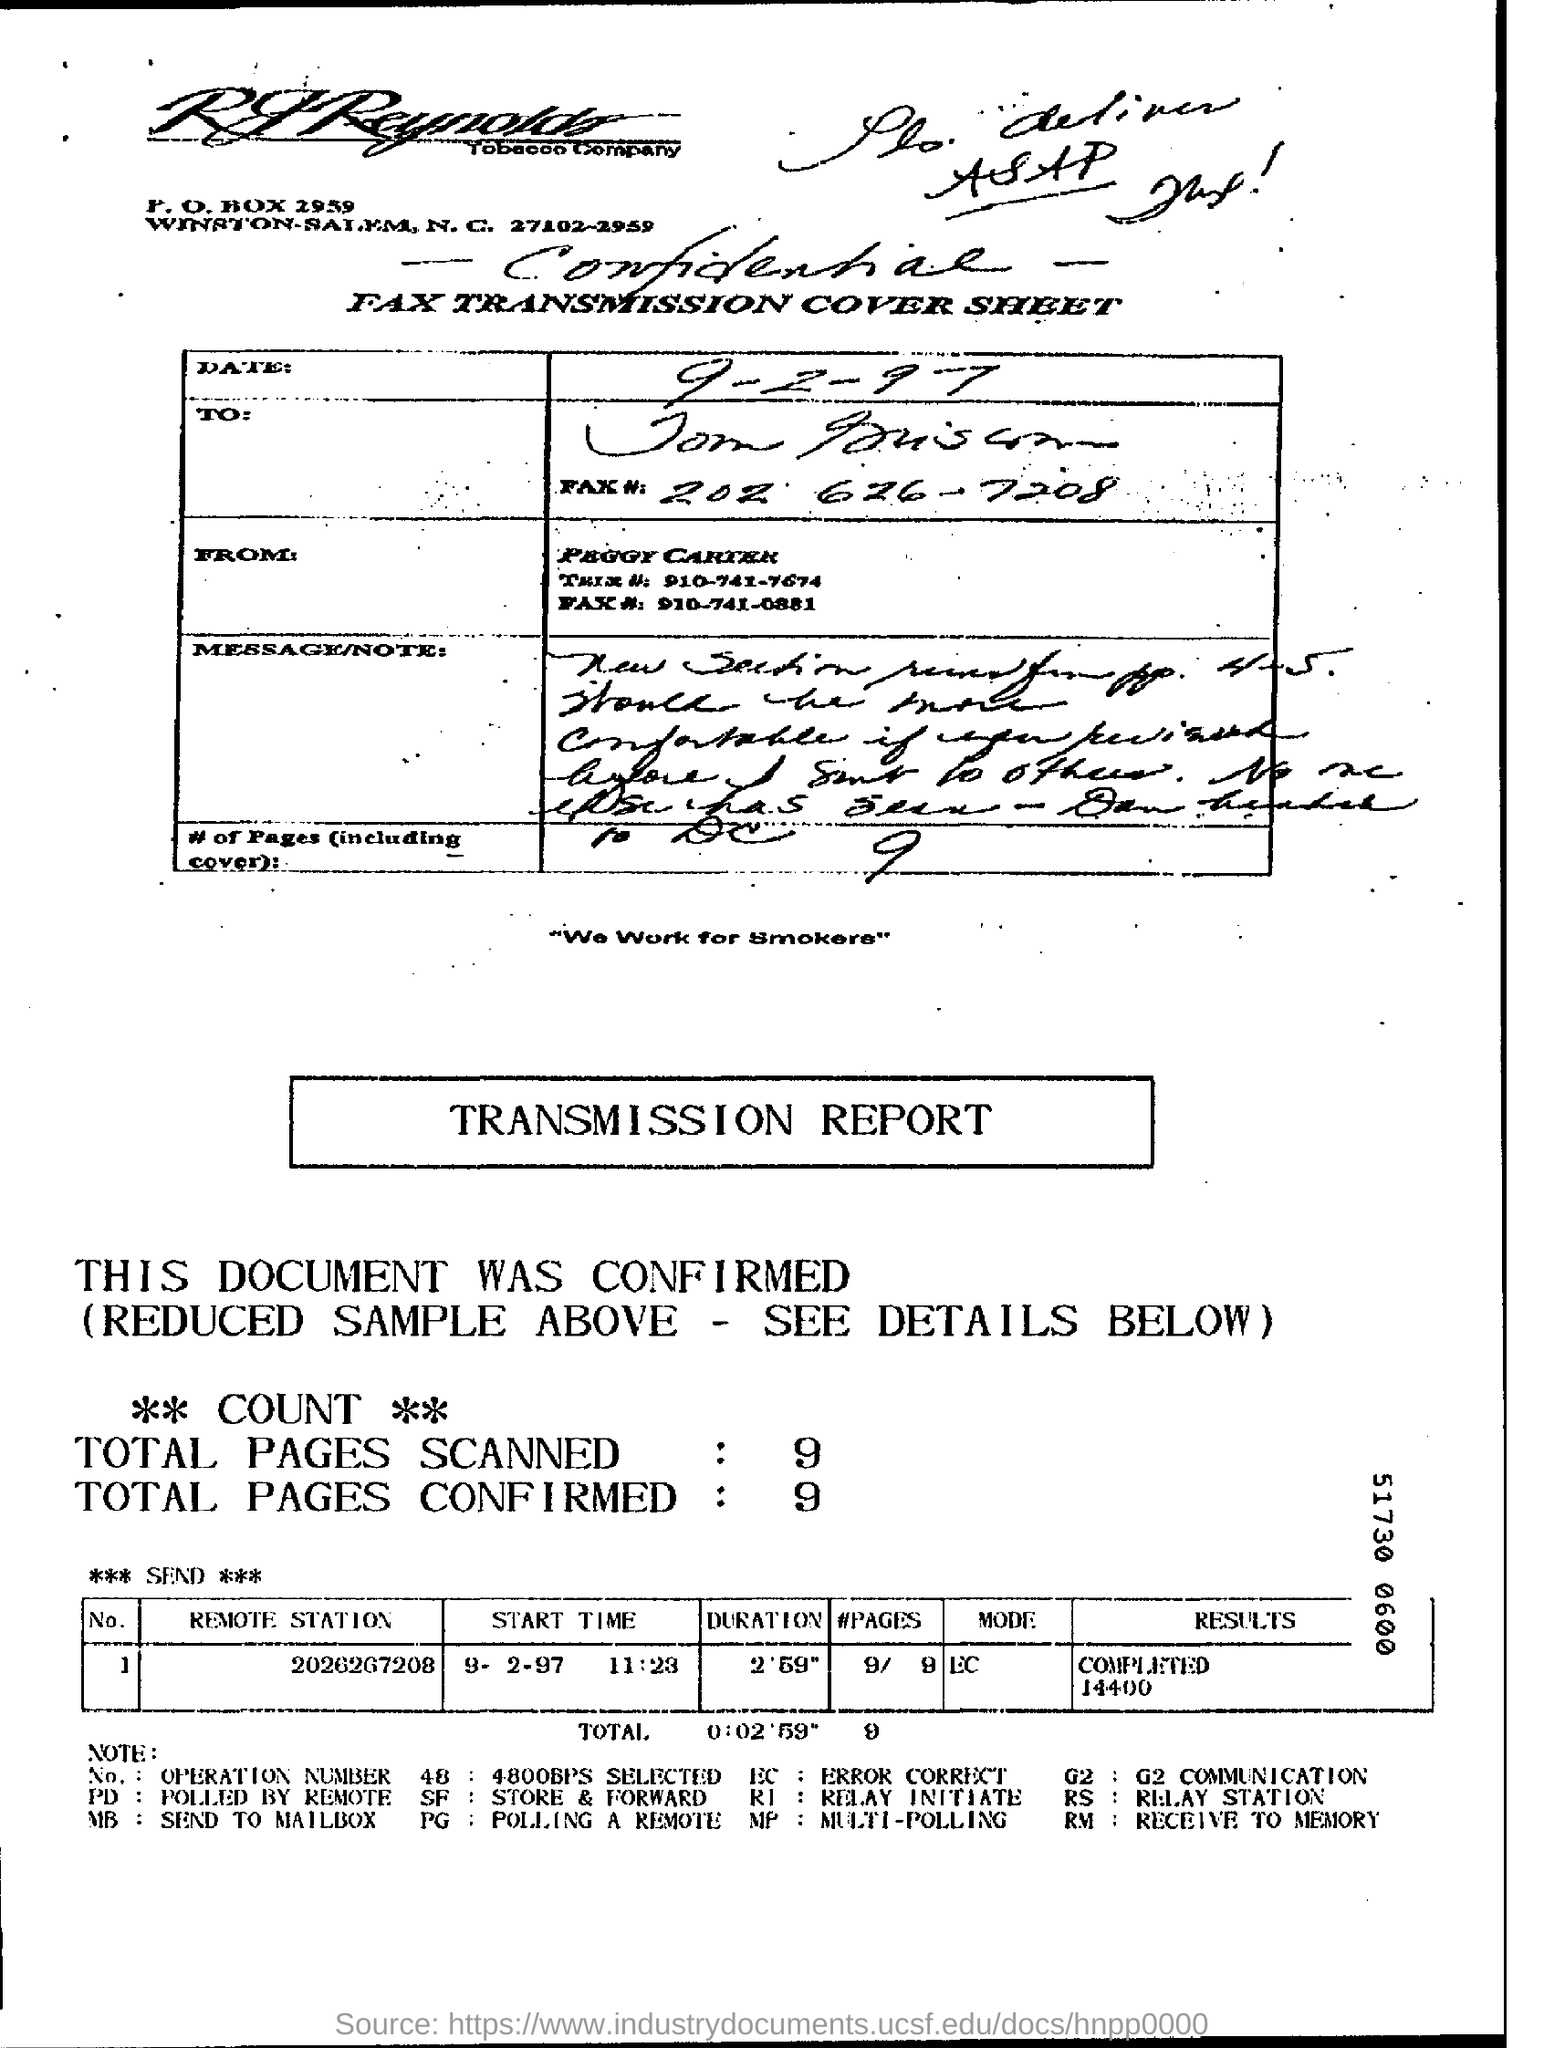What  was the duration  taken to finish this process?
Keep it short and to the point. 2.59". How many number of pages were scanned?
Your response must be concise. 9. 